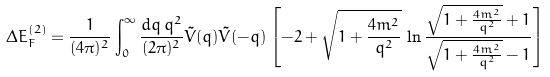<formula> <loc_0><loc_0><loc_500><loc_500>\Delta E _ { F } ^ { ( 2 ) } = \frac { 1 } { ( 4 \pi ) ^ { 2 } } \int _ { 0 } ^ { \infty } \frac { d q \, q ^ { 2 } } { ( 2 \pi ) ^ { 2 } } \tilde { V } ( q ) \tilde { V } ( - q ) \left [ - 2 + \sqrt { 1 + \frac { 4 m ^ { 2 } } { q ^ { 2 } } } \, \ln \frac { \sqrt { 1 + \frac { 4 m ^ { 2 } } { q ^ { 2 } } } + 1 } { \sqrt { 1 + \frac { 4 m ^ { 2 } } { q ^ { 2 } } } - 1 } \right ]</formula> 